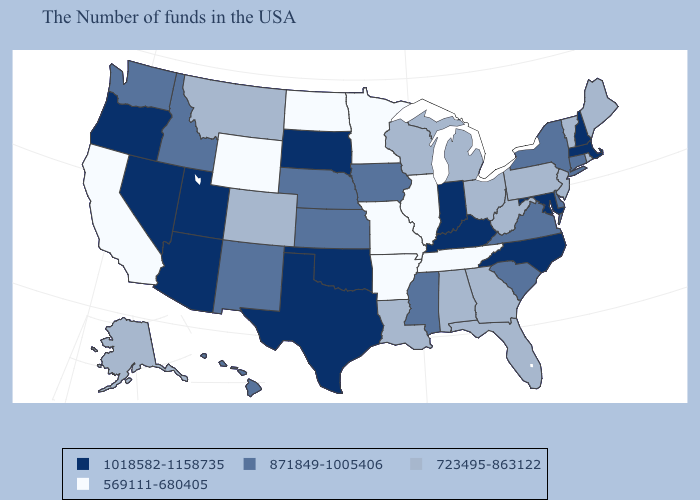Is the legend a continuous bar?
Concise answer only. No. What is the value of Idaho?
Concise answer only. 871849-1005406. What is the lowest value in the South?
Concise answer only. 569111-680405. What is the value of Idaho?
Be succinct. 871849-1005406. What is the lowest value in states that border Minnesota?
Write a very short answer. 569111-680405. Does Virginia have the lowest value in the South?
Concise answer only. No. Does Arkansas have the lowest value in the South?
Quick response, please. Yes. Does the first symbol in the legend represent the smallest category?
Short answer required. No. Name the states that have a value in the range 723495-863122?
Answer briefly. Maine, Rhode Island, Vermont, New Jersey, Pennsylvania, West Virginia, Ohio, Florida, Georgia, Michigan, Alabama, Wisconsin, Louisiana, Colorado, Montana, Alaska. Name the states that have a value in the range 723495-863122?
Keep it brief. Maine, Rhode Island, Vermont, New Jersey, Pennsylvania, West Virginia, Ohio, Florida, Georgia, Michigan, Alabama, Wisconsin, Louisiana, Colorado, Montana, Alaska. Among the states that border Iowa , does Nebraska have the lowest value?
Answer briefly. No. Does Colorado have the highest value in the USA?
Keep it brief. No. Which states have the lowest value in the USA?
Answer briefly. Tennessee, Illinois, Missouri, Arkansas, Minnesota, North Dakota, Wyoming, California. Name the states that have a value in the range 871849-1005406?
Concise answer only. Connecticut, New York, Delaware, Virginia, South Carolina, Mississippi, Iowa, Kansas, Nebraska, New Mexico, Idaho, Washington, Hawaii. Name the states that have a value in the range 723495-863122?
Write a very short answer. Maine, Rhode Island, Vermont, New Jersey, Pennsylvania, West Virginia, Ohio, Florida, Georgia, Michigan, Alabama, Wisconsin, Louisiana, Colorado, Montana, Alaska. 